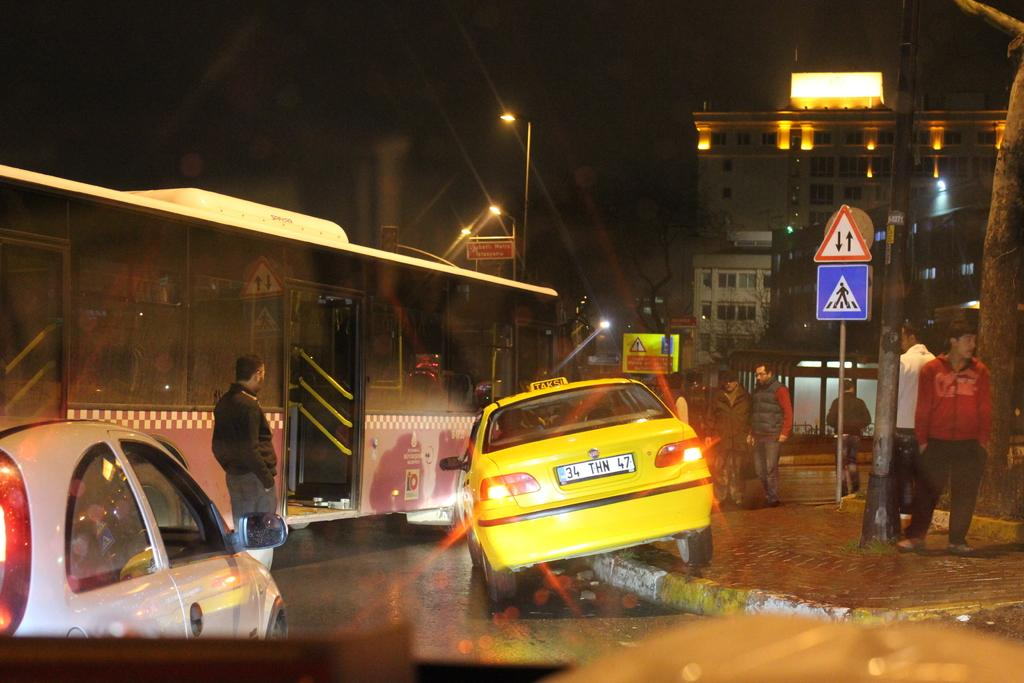What type of vehicle is in the image? There is a bus in the image. Are there any people in the image? Yes, there are people in the image. What other vehicles can be seen in the image? There are cars in the image. What type of street furniture is present in the image? There are street lamps in the image. What structure is visible in the image? There is a sign pole in the image. What type of building is in the image? There is a building in the image. What part of the natural environment is visible in the image? The sky is visible in the image. How is the lighting described in the image? The image is described as being a little dark. What type of marble can be seen in the image? There is no marble present in the image. Is there an alley visible in the image? There is no alley visible in the image. What type of boat can be seen in the image? There is no boat present in the image. 